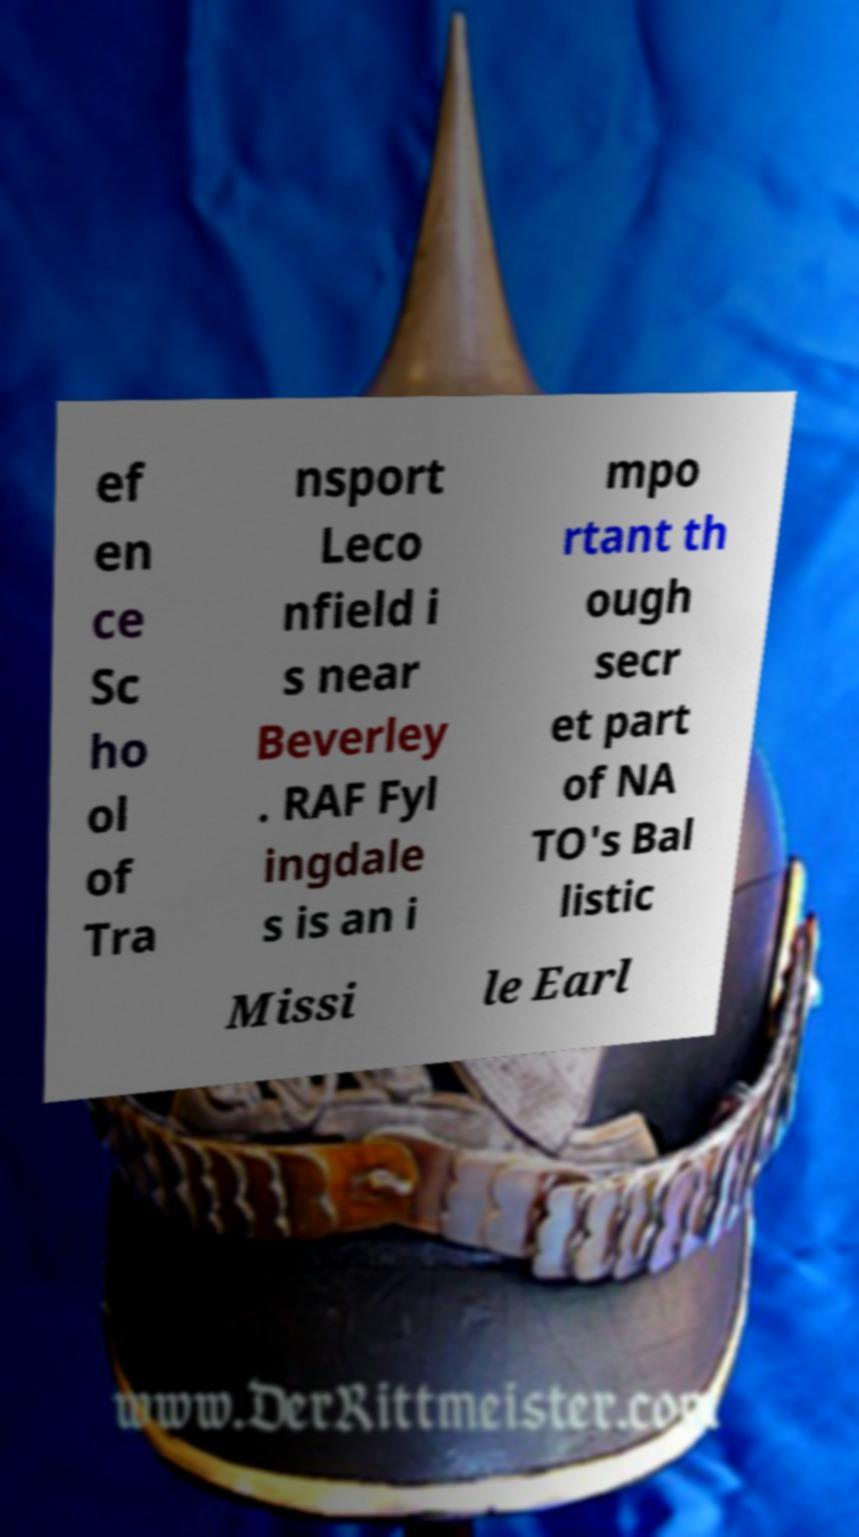Can you accurately transcribe the text from the provided image for me? ef en ce Sc ho ol of Tra nsport Leco nfield i s near Beverley . RAF Fyl ingdale s is an i mpo rtant th ough secr et part of NA TO's Bal listic Missi le Earl 